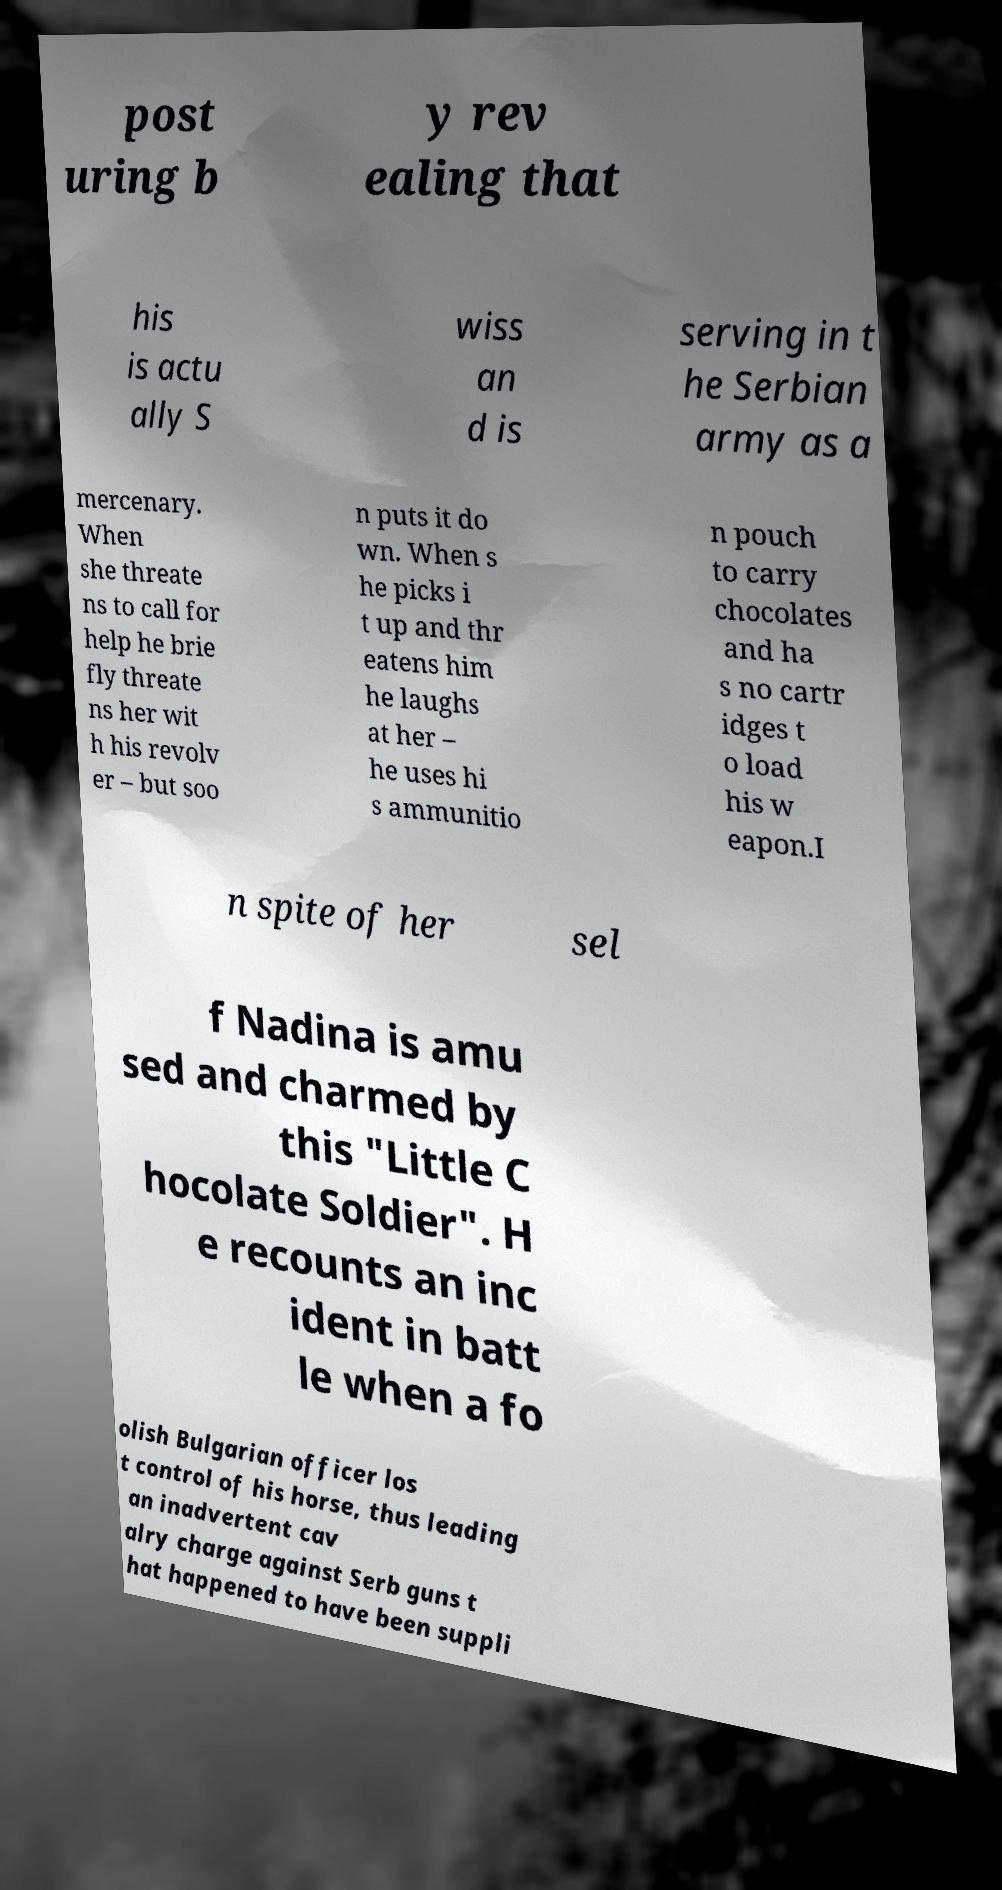I need the written content from this picture converted into text. Can you do that? post uring b y rev ealing that his is actu ally S wiss an d is serving in t he Serbian army as a mercenary. When she threate ns to call for help he brie fly threate ns her wit h his revolv er – but soo n puts it do wn. When s he picks i t up and thr eatens him he laughs at her – he uses hi s ammunitio n pouch to carry chocolates and ha s no cartr idges t o load his w eapon.I n spite of her sel f Nadina is amu sed and charmed by this "Little C hocolate Soldier". H e recounts an inc ident in batt le when a fo olish Bulgarian officer los t control of his horse, thus leading an inadvertent cav alry charge against Serb guns t hat happened to have been suppli 